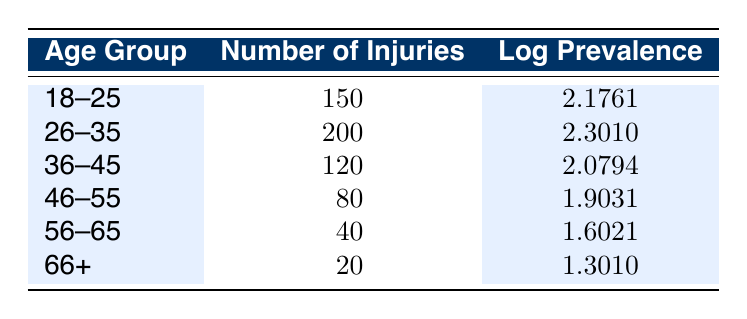What is the age group with the highest number of injuries? By looking at the "Number of Injuries" column, we can see that the "26-35" age group has the highest value at 200 injuries.
Answer: 26-35 How many injuries are reported for the age group 46-55? The number of injuries listed for the age group "46-55" in the table is 80.
Answer: 80 What is the logarithmic prevalence for the age group 56-65? Referring to the "Log Prevalence" column, the logarithmic prevalence for the "56-65" age group is 1.6021.
Answer: 1.6021 What is the total number of injuries for age groups 18-25 and 36-45 combined? To find the total injuries, we add the number of injuries from both age groups: 150 (18-25) + 120 (36-45) = 270.
Answer: 270 Is the logarithmic prevalence higher for the 36-45 age group than for the 46-55 age group? The logarithmic prevalence for "36-45" is 2.0794, while for "46-55," it is 1.9031. Since 2.0794 is greater than 1.9031, the statement is true.
Answer: Yes What is the average number of injuries across all age groups? First, we sum the total number of injuries: 150 + 200 + 120 + 80 + 40 + 20 = 610. There are 6 age groups, so the average is 610 / 6 = 101.67.
Answer: 101.67 Which age group has the lowest logarithmic prevalence? Looking at the "Log Prevalence" column, the "66+" age group has the lowest value at 1.3010.
Answer: 66+ Is it true that all age groups have a logarithmic prevalence greater than 1? Reviewing the "Log Prevalence" values, all groups except "66+" have values greater than 1. Therefore, the statement is false.
Answer: No What is the difference in the number of injuries between age groups 26-35 and 56-65? The difference is calculated by subtracting the injuries in "56-65" from "26-35": 200 (26-35) - 40 (56-65) = 160 injuries.
Answer: 160 